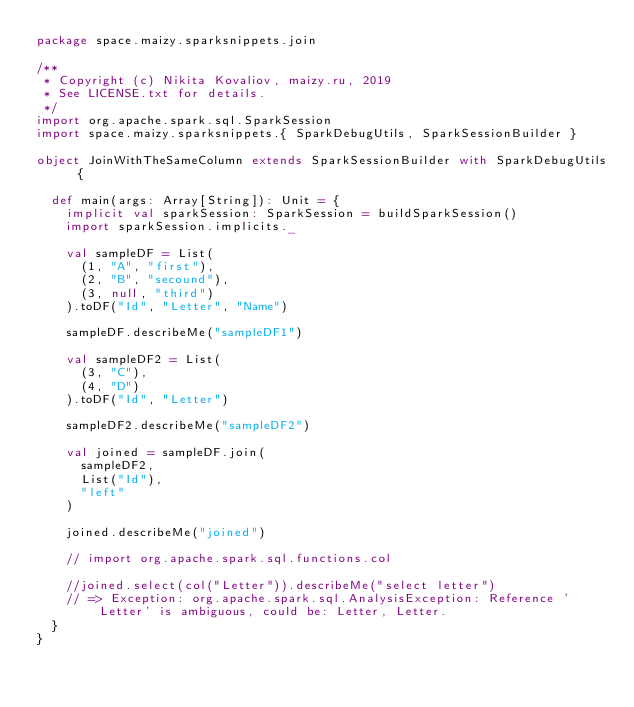<code> <loc_0><loc_0><loc_500><loc_500><_Scala_>package space.maizy.sparksnippets.join

/**
 * Copyright (c) Nikita Kovaliov, maizy.ru, 2019
 * See LICENSE.txt for details.
 */
import org.apache.spark.sql.SparkSession
import space.maizy.sparksnippets.{ SparkDebugUtils, SparkSessionBuilder }

object JoinWithTheSameColumn extends SparkSessionBuilder with SparkDebugUtils {

  def main(args: Array[String]): Unit = {
    implicit val sparkSession: SparkSession = buildSparkSession()
    import sparkSession.implicits._

    val sampleDF = List(
      (1, "A", "first"),
      (2, "B", "secound"),
      (3, null, "third")
    ).toDF("Id", "Letter", "Name")

    sampleDF.describeMe("sampleDF1")

    val sampleDF2 = List(
      (3, "C"),
      (4, "D")
    ).toDF("Id", "Letter")

    sampleDF2.describeMe("sampleDF2")

    val joined = sampleDF.join(
      sampleDF2,
      List("Id"),
      "left"
    )

    joined.describeMe("joined")

    // import org.apache.spark.sql.functions.col

    //joined.select(col("Letter")).describeMe("select letter")
    // => Exception: org.apache.spark.sql.AnalysisException: Reference 'Letter' is ambiguous, could be: Letter, Letter.
  }
}
</code> 